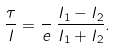<formula> <loc_0><loc_0><loc_500><loc_500>\frac { \tau } { I } = \frac { } { e } \, \frac { I _ { 1 } - I _ { 2 } } { I _ { 1 } + I _ { 2 } } .</formula> 